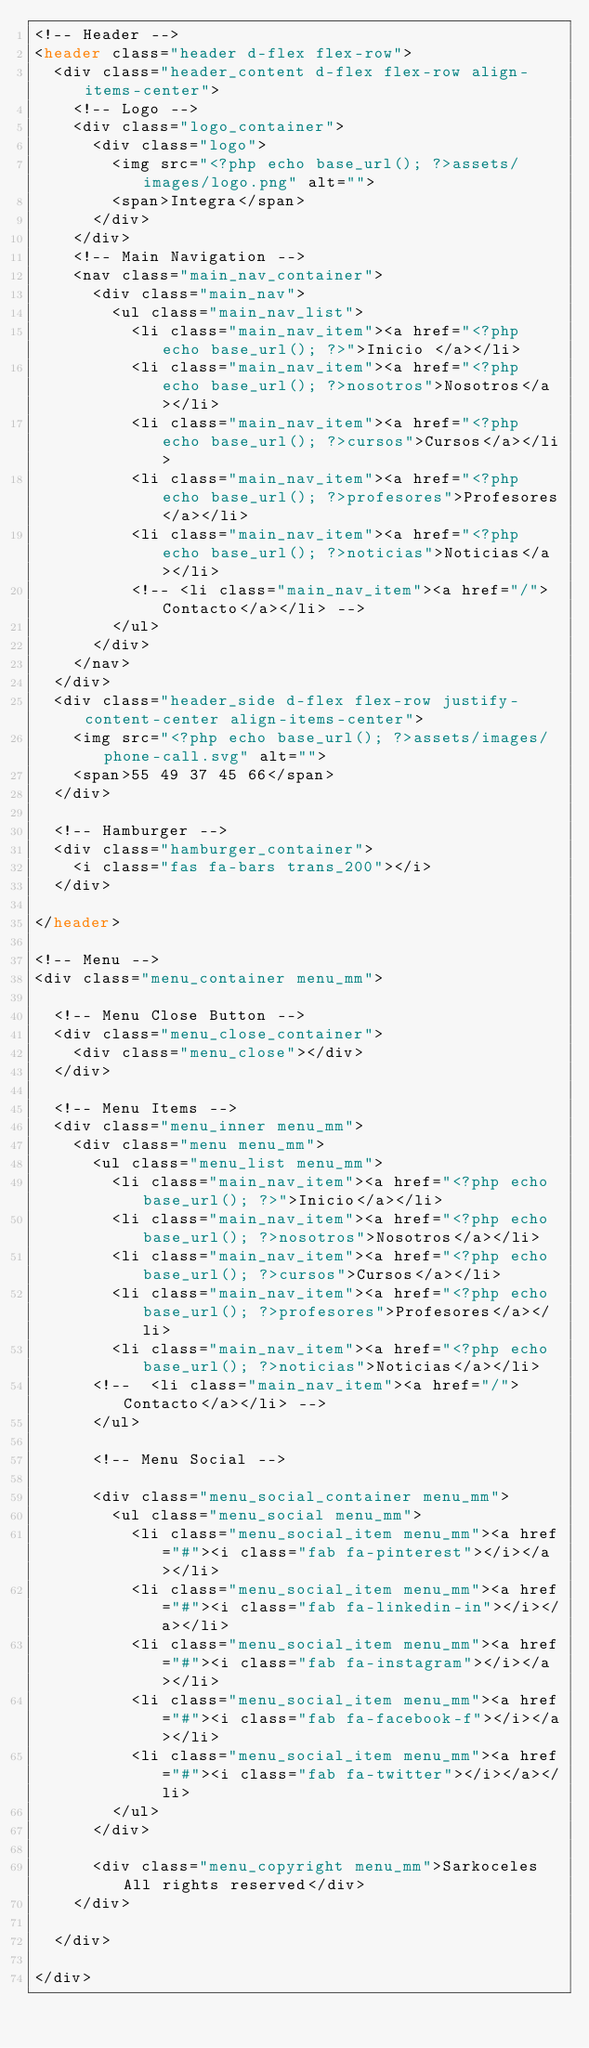<code> <loc_0><loc_0><loc_500><loc_500><_PHP_><!-- Header -->
<header class="header d-flex flex-row">
	<div class="header_content d-flex flex-row align-items-center">
		<!-- Logo -->
		<div class="logo_container">
			<div class="logo">
				<img src="<?php echo base_url(); ?>assets/images/logo.png" alt="">
				<span>Integra</span>
			</div>
		</div>
		<!-- Main Navigation -->
		<nav class="main_nav_container">
			<div class="main_nav">
				<ul class="main_nav_list">
					<li class="main_nav_item"><a href="<?php echo base_url(); ?>">Inicio </a></li>
					<li class="main_nav_item"><a href="<?php echo base_url(); ?>nosotros">Nosotros</a></li>
					<li class="main_nav_item"><a href="<?php echo base_url(); ?>cursos">Cursos</a></li>
					<li class="main_nav_item"><a href="<?php echo base_url(); ?>profesores">Profesores</a></li>
					<li class="main_nav_item"><a href="<?php echo base_url(); ?>noticias">Noticias</a></li>
					<!-- <li class="main_nav_item"><a href="/">Contacto</a></li> -->
				</ul>
			</div>
		</nav>
	</div>
	<div class="header_side d-flex flex-row justify-content-center align-items-center">
		<img src="<?php echo base_url(); ?>assets/images/phone-call.svg" alt="">
		<span>55 49 37 45 66</span>
	</div>

	<!-- Hamburger -->
	<div class="hamburger_container">
		<i class="fas fa-bars trans_200"></i>
	</div>

</header>

<!-- Menu -->
<div class="menu_container menu_mm">

	<!-- Menu Close Button -->
	<div class="menu_close_container">
		<div class="menu_close"></div>
	</div>

	<!-- Menu Items -->
	<div class="menu_inner menu_mm">
		<div class="menu menu_mm">
			<ul class="menu_list menu_mm">
				<li class="main_nav_item"><a href="<?php echo base_url(); ?>">Inicio</a></li>
				<li class="main_nav_item"><a href="<?php echo base_url(); ?>nosotros">Nosotros</a></li>
				<li class="main_nav_item"><a href="<?php echo base_url(); ?>cursos">Cursos</a></li>
				<li class="main_nav_item"><a href="<?php echo base_url(); ?>profesores">Profesores</a></li>
				<li class="main_nav_item"><a href="<?php echo base_url(); ?>noticias">Noticias</a></li>
			<!-- 	<li class="main_nav_item"><a href="/">Contacto</a></li> -->
			</ul>

			<!-- Menu Social -->

			<div class="menu_social_container menu_mm">
				<ul class="menu_social menu_mm">
					<li class="menu_social_item menu_mm"><a href="#"><i class="fab fa-pinterest"></i></a></li>
					<li class="menu_social_item menu_mm"><a href="#"><i class="fab fa-linkedin-in"></i></a></li>
					<li class="menu_social_item menu_mm"><a href="#"><i class="fab fa-instagram"></i></a></li>
					<li class="menu_social_item menu_mm"><a href="#"><i class="fab fa-facebook-f"></i></a></li>
					<li class="menu_social_item menu_mm"><a href="#"><i class="fab fa-twitter"></i></a></li>
				</ul>
			</div>

			<div class="menu_copyright menu_mm">Sarkoceles All rights reserved</div>
		</div>

	</div>

</div></code> 